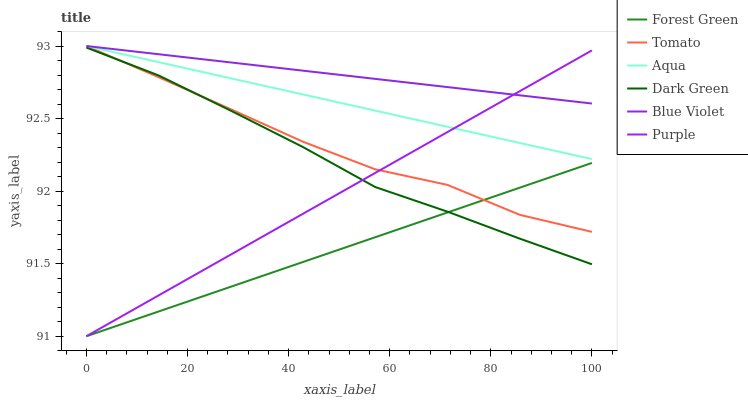Does Forest Green have the minimum area under the curve?
Answer yes or no. Yes. Does Blue Violet have the maximum area under the curve?
Answer yes or no. Yes. Does Purple have the minimum area under the curve?
Answer yes or no. No. Does Purple have the maximum area under the curve?
Answer yes or no. No. Is Forest Green the smoothest?
Answer yes or no. Yes. Is Tomato the roughest?
Answer yes or no. Yes. Is Purple the smoothest?
Answer yes or no. No. Is Purple the roughest?
Answer yes or no. No. Does Purple have the lowest value?
Answer yes or no. Yes. Does Aqua have the lowest value?
Answer yes or no. No. Does Blue Violet have the highest value?
Answer yes or no. Yes. Does Purple have the highest value?
Answer yes or no. No. Is Dark Green less than Aqua?
Answer yes or no. Yes. Is Blue Violet greater than Dark Green?
Answer yes or no. Yes. Does Purple intersect Forest Green?
Answer yes or no. Yes. Is Purple less than Forest Green?
Answer yes or no. No. Is Purple greater than Forest Green?
Answer yes or no. No. Does Dark Green intersect Aqua?
Answer yes or no. No. 